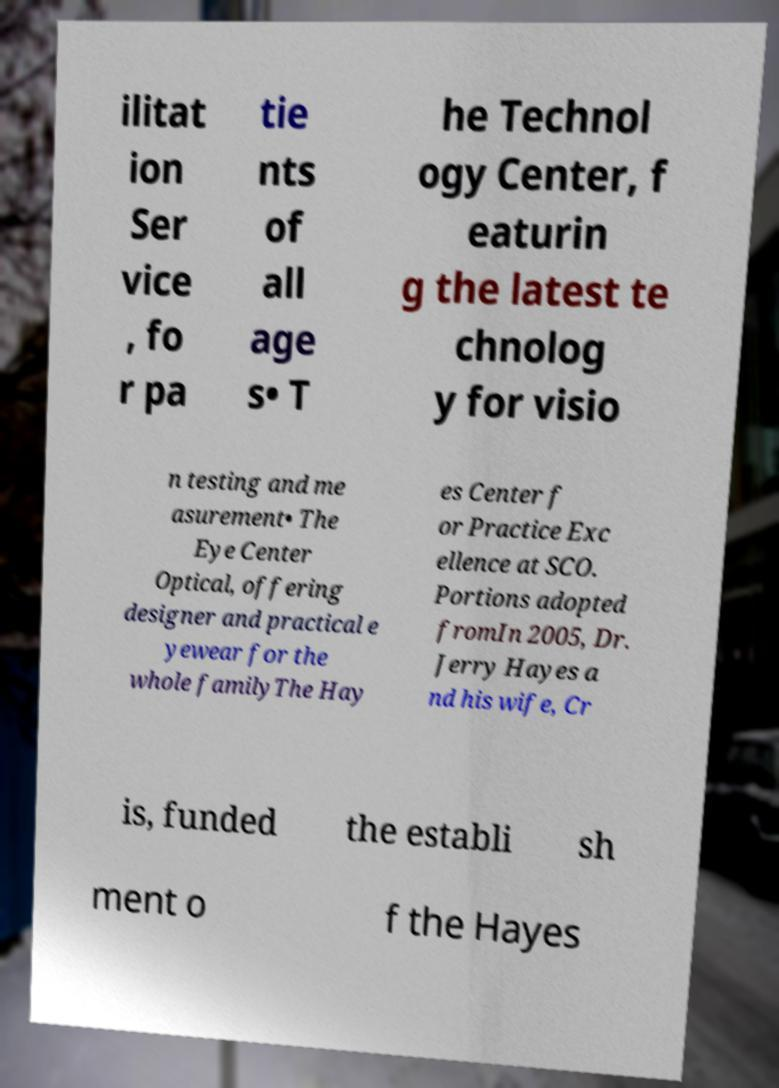There's text embedded in this image that I need extracted. Can you transcribe it verbatim? ilitat ion Ser vice , fo r pa tie nts of all age s• T he Technol ogy Center, f eaturin g the latest te chnolog y for visio n testing and me asurement• The Eye Center Optical, offering designer and practical e yewear for the whole familyThe Hay es Center f or Practice Exc ellence at SCO. Portions adopted fromIn 2005, Dr. Jerry Hayes a nd his wife, Cr is, funded the establi sh ment o f the Hayes 